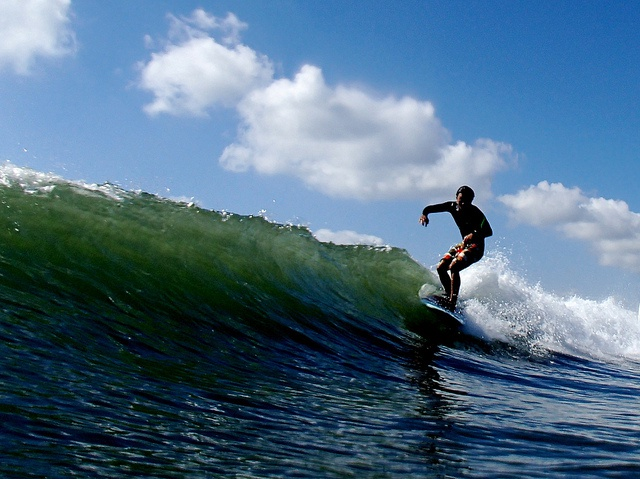Describe the objects in this image and their specific colors. I can see people in lavender, black, gray, maroon, and darkgray tones and surfboard in lavender, black, blue, gray, and navy tones in this image. 